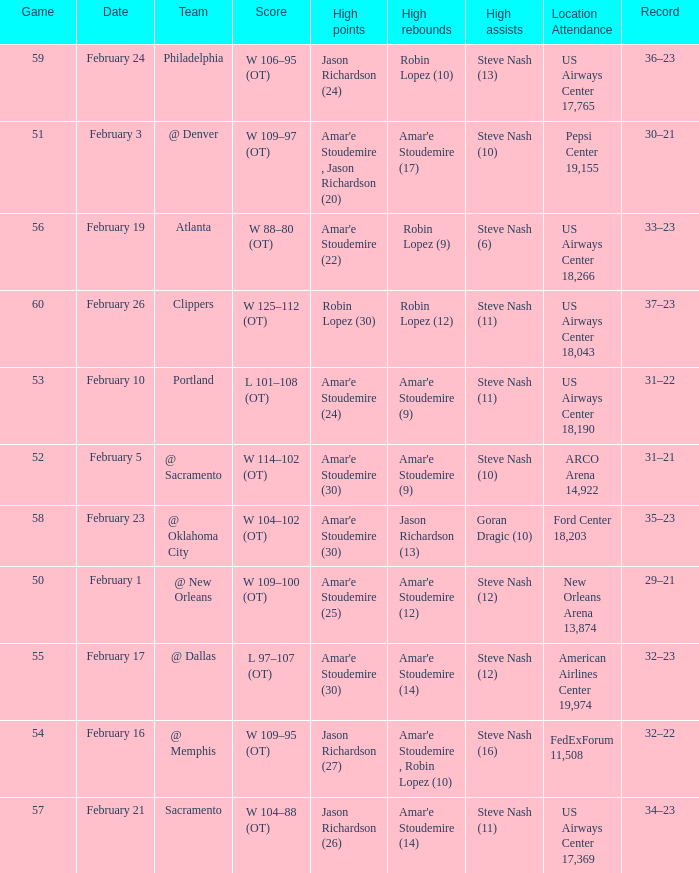Name the high points for pepsi center 19,155 Amar'e Stoudemire , Jason Richardson (20). 